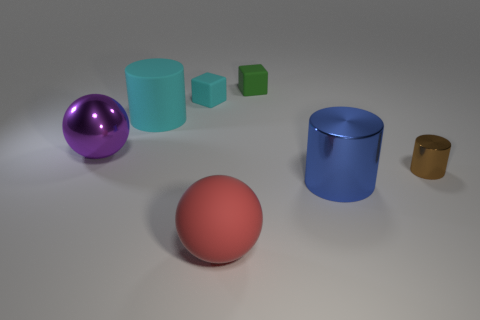What number of other things are the same material as the small cyan thing?
Keep it short and to the point. 3. Is the red thing made of the same material as the large cylinder behind the brown metal cylinder?
Keep it short and to the point. Yes. Are there fewer big objects on the right side of the brown metallic object than large cyan matte things left of the large cyan thing?
Provide a succinct answer. No. What is the color of the small block that is right of the big red matte sphere?
Your response must be concise. Green. How many other things are there of the same color as the small shiny thing?
Provide a succinct answer. 0. There is a ball that is in front of the brown metallic cylinder; is its size the same as the big cyan matte object?
Your response must be concise. Yes. There is a large red sphere; what number of small things are to the left of it?
Give a very brief answer. 1. Is there a purple metallic cylinder of the same size as the blue metallic object?
Make the answer very short. No. Is the color of the large rubber sphere the same as the large metallic cylinder?
Your answer should be compact. No. What is the color of the metal cylinder in front of the thing that is on the right side of the large blue thing?
Give a very brief answer. Blue. 